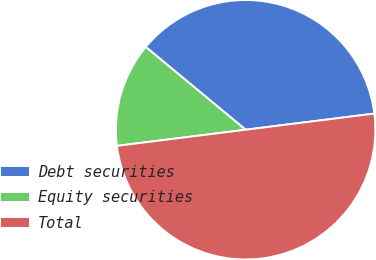Convert chart. <chart><loc_0><loc_0><loc_500><loc_500><pie_chart><fcel>Debt securities<fcel>Equity securities<fcel>Total<nl><fcel>37.0%<fcel>13.0%<fcel>50.0%<nl></chart> 